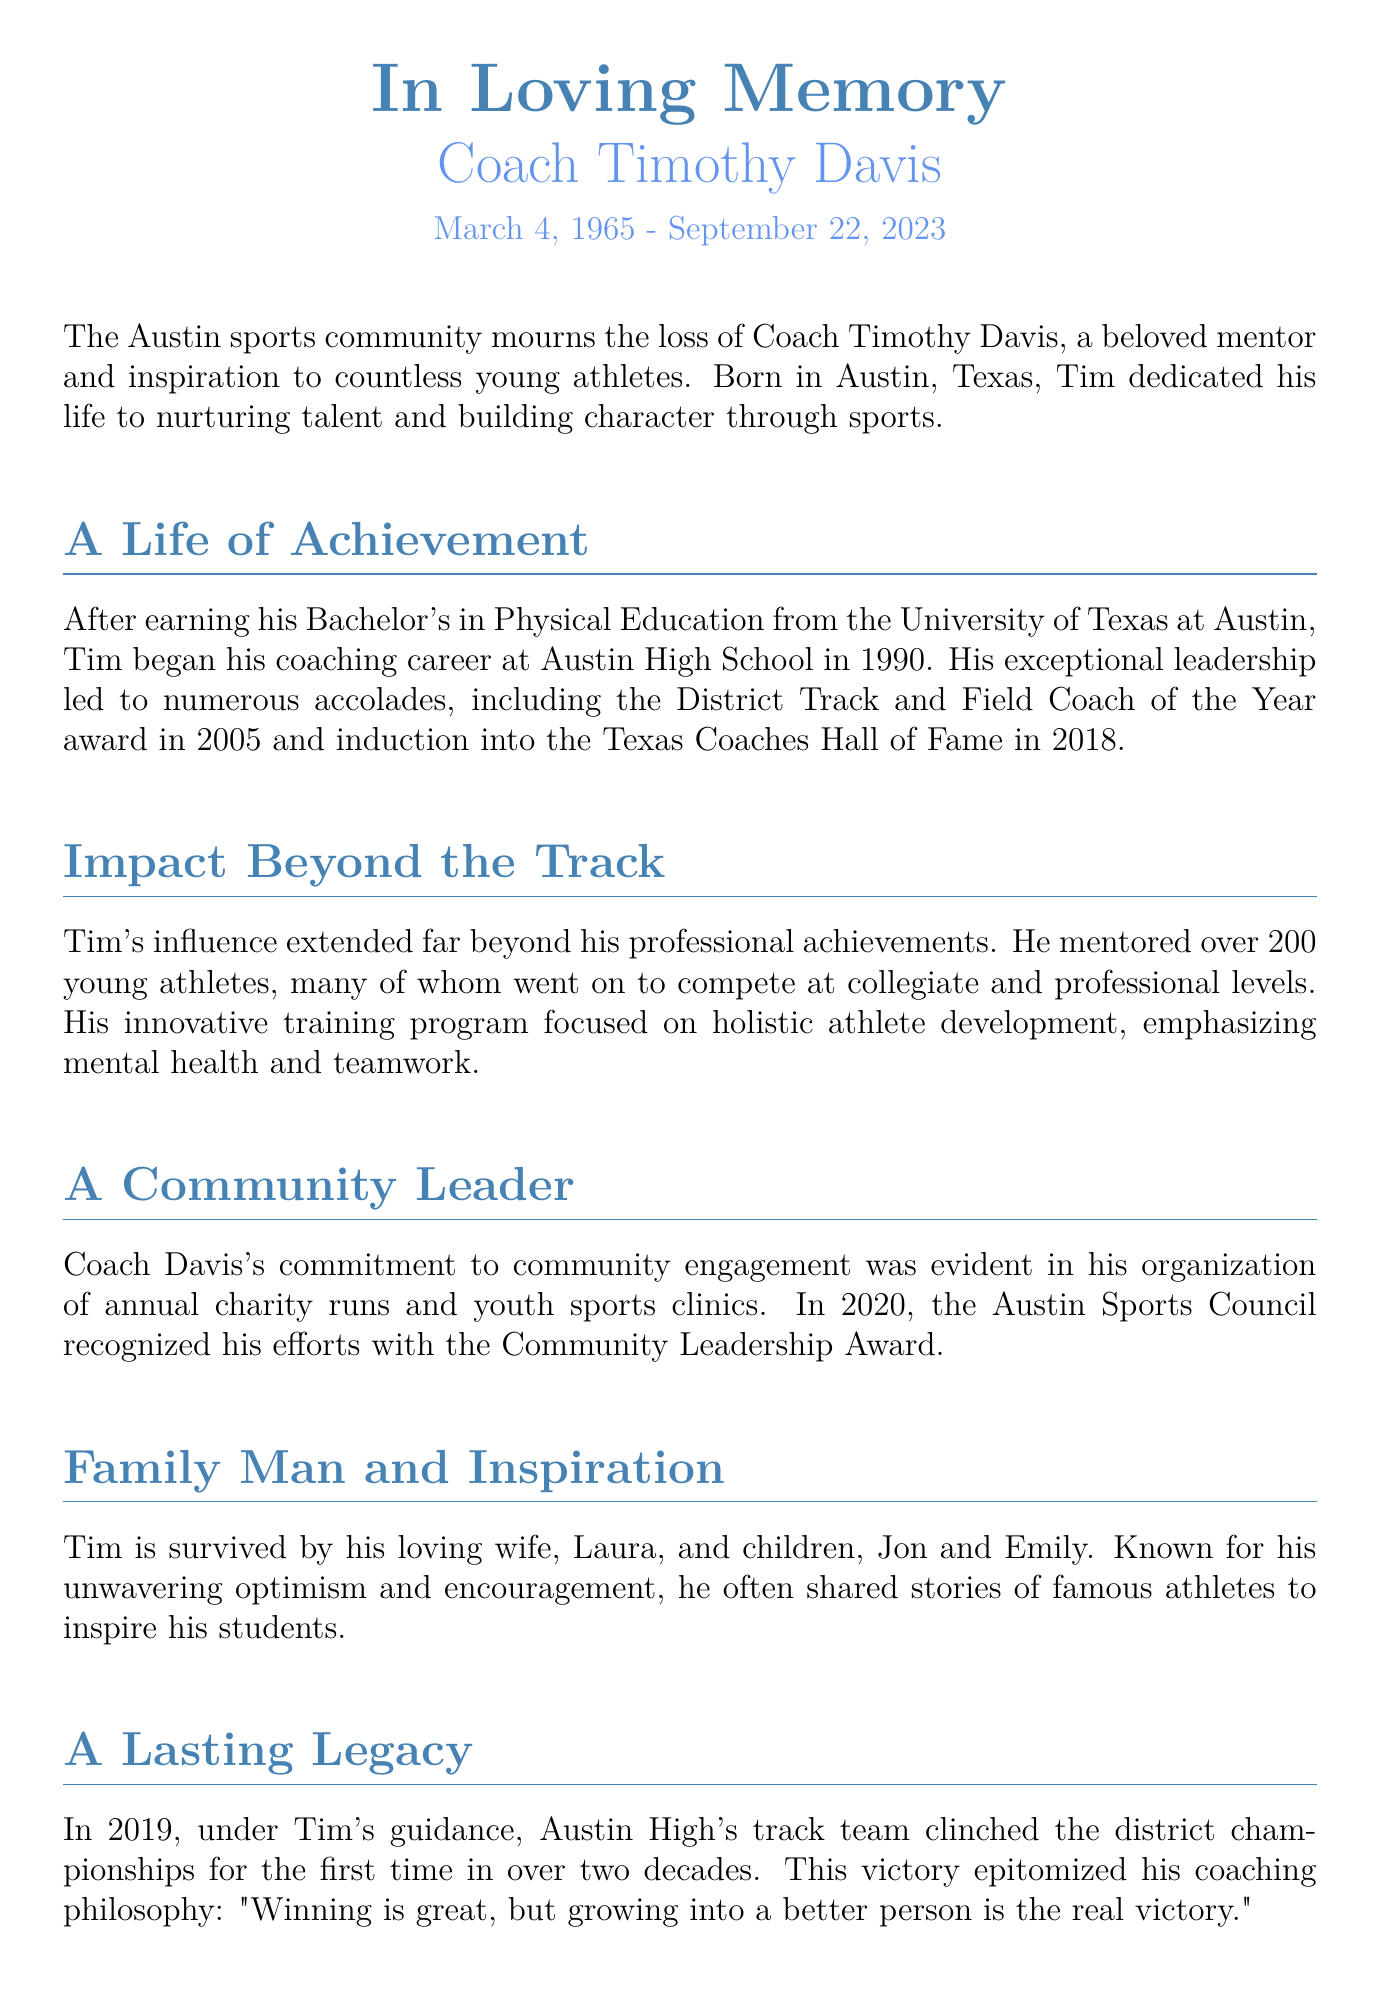What was Coach Timothy Davis's date of birth? The document states that Coach Timothy Davis was born on March 4, 1965.
Answer: March 4, 1965 In which year did Coach Davis join Austin High School? The document mentions that Tim began his coaching career at Austin High School in 1990.
Answer: 1990 How many young athletes did Coach Davis mentor? The document states that he mentored over 200 young athletes.
Answer: Over 200 Which award did Coach Davis receive in 2005? The document notes that he received the District Track and Field Coach of the Year award in 2005.
Answer: District Track and Field Coach of the Year What was Tim’s coaching philosophy regarding winning? The document quotes his philosophy: "Winning is great, but growing into a better person is the real victory."
Answer: "Winning is great, but growing into a better person is the real victory." What significant achievement did the track team accomplish in 2019? The document states that under Tim's guidance, Austin High's track team clinched the district championships for the first time in over two decades in 2019.
Answer: District championships Who was recognized with the Community Leadership Award in 2020? The document states that Tim was recognized with the Community Leadership Award in 2020.
Answer: Tim Who referred to Coach Davis as "like a second father"? The document cites Jane Smith, a former student, as referring to Coach Davis in this way.
Answer: Jane Smith 